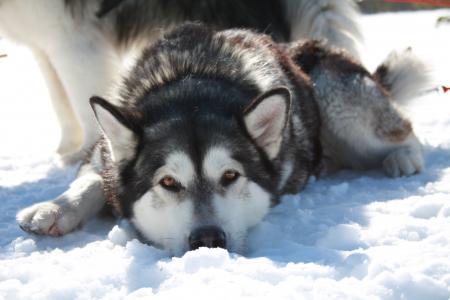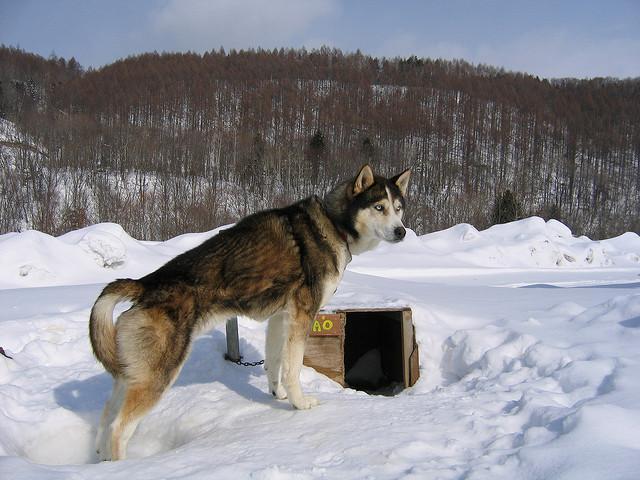The first image is the image on the left, the second image is the image on the right. Given the left and right images, does the statement "in at least one image the is a brown and white husky outside in the snow standing." hold true? Answer yes or no. Yes. The first image is the image on the left, the second image is the image on the right. Evaluate the accuracy of this statement regarding the images: "All dogs are in snowy scenes, and the left image features a reclining black-and-white husky, while the right image features an upright husky.". Is it true? Answer yes or no. Yes. 